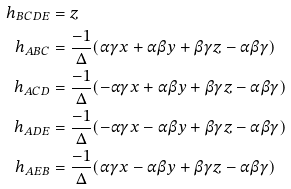<formula> <loc_0><loc_0><loc_500><loc_500>h _ { B C D E } & = z \\ h _ { A B C } & = \frac { - 1 } { \Delta } ( \alpha \gamma x + \alpha \beta y + \beta \gamma z - \alpha \beta \gamma ) \\ h _ { A C D } & = \frac { - 1 } { \Delta } ( - \alpha \gamma x + \alpha \beta y + \beta \gamma z - \alpha \beta \gamma ) \\ h _ { A D E } & = \frac { - 1 } { \Delta } ( - \alpha \gamma x - \alpha \beta y + \beta \gamma z - \alpha \beta \gamma ) \\ h _ { A E B } & = \frac { - 1 } { \Delta } ( \alpha \gamma x - \alpha \beta y + \beta \gamma z - \alpha \beta \gamma )</formula> 